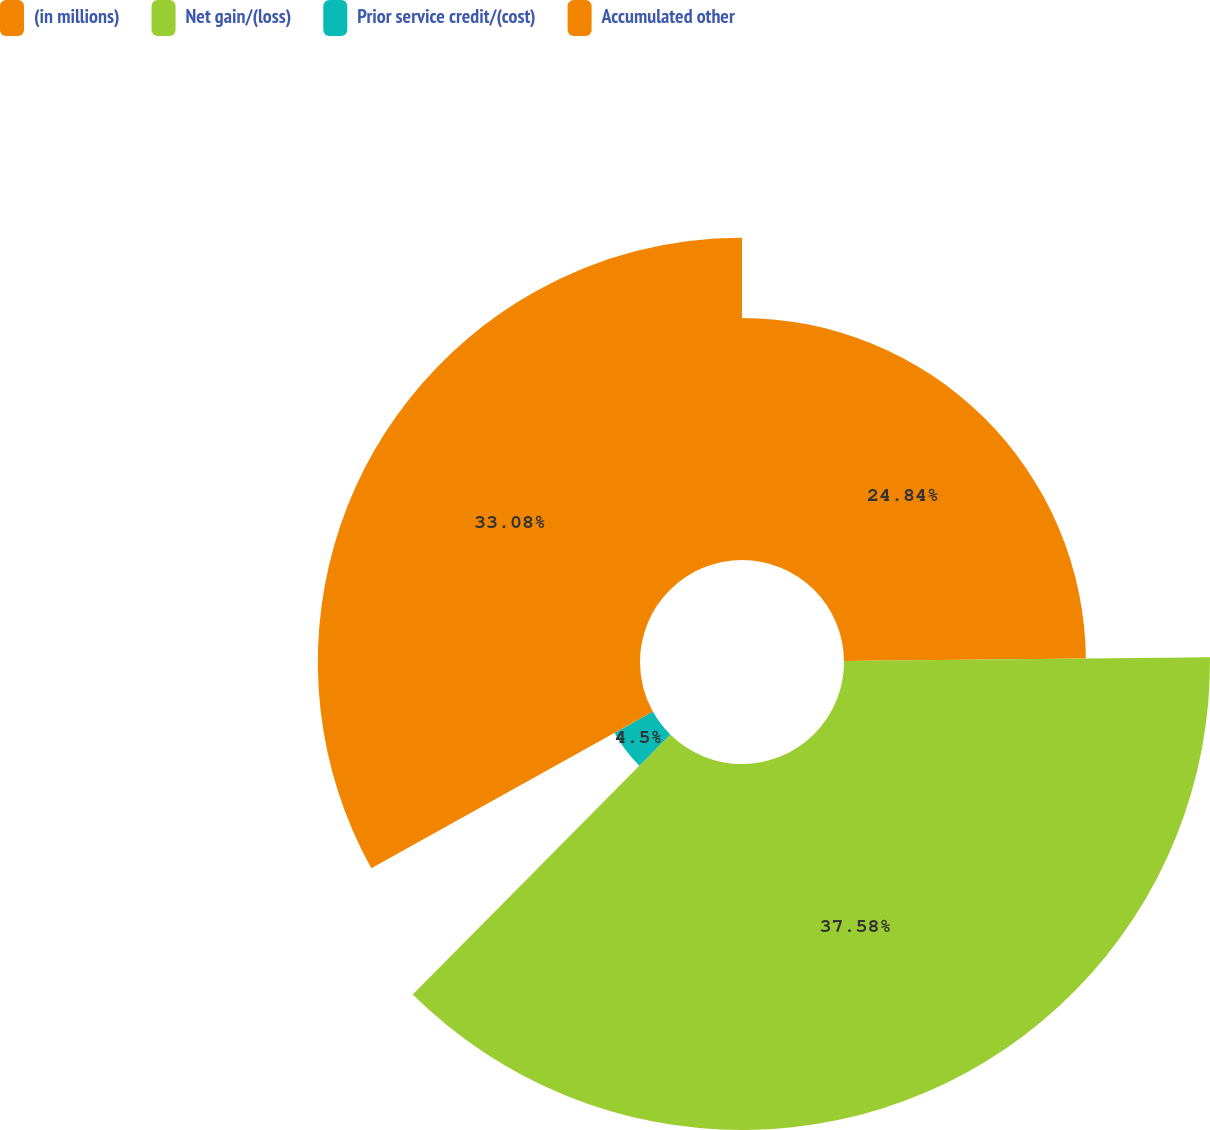<chart> <loc_0><loc_0><loc_500><loc_500><pie_chart><fcel>(in millions)<fcel>Net gain/(loss)<fcel>Prior service credit/(cost)<fcel>Accumulated other<nl><fcel>24.84%<fcel>37.58%<fcel>4.5%<fcel>33.08%<nl></chart> 